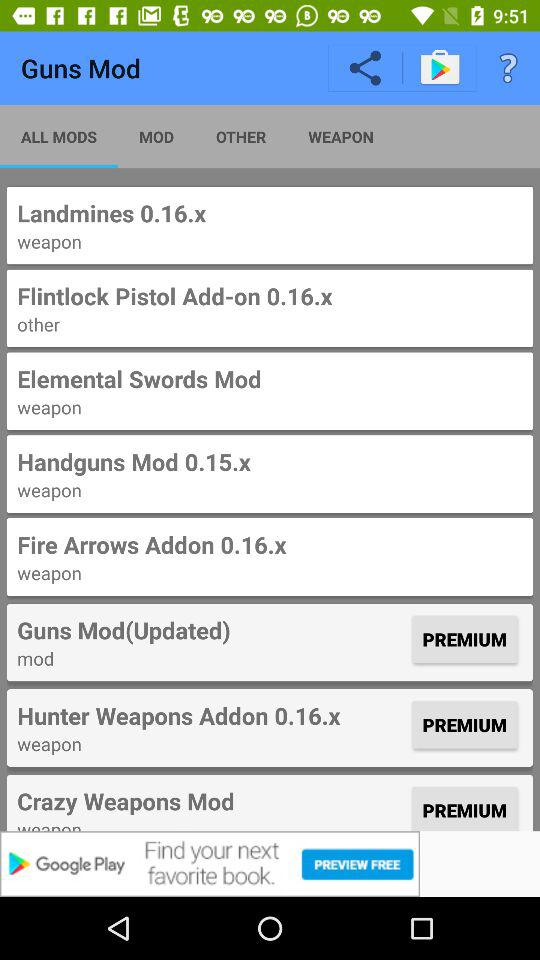Which "Guns Mod" is included in the premium package? The "Guns Mod" that are included in the premium package are "Guns Mod(Updated)", "Hunter Weapons Addon 0.16.x" and "Crazy Weapons Mod". 